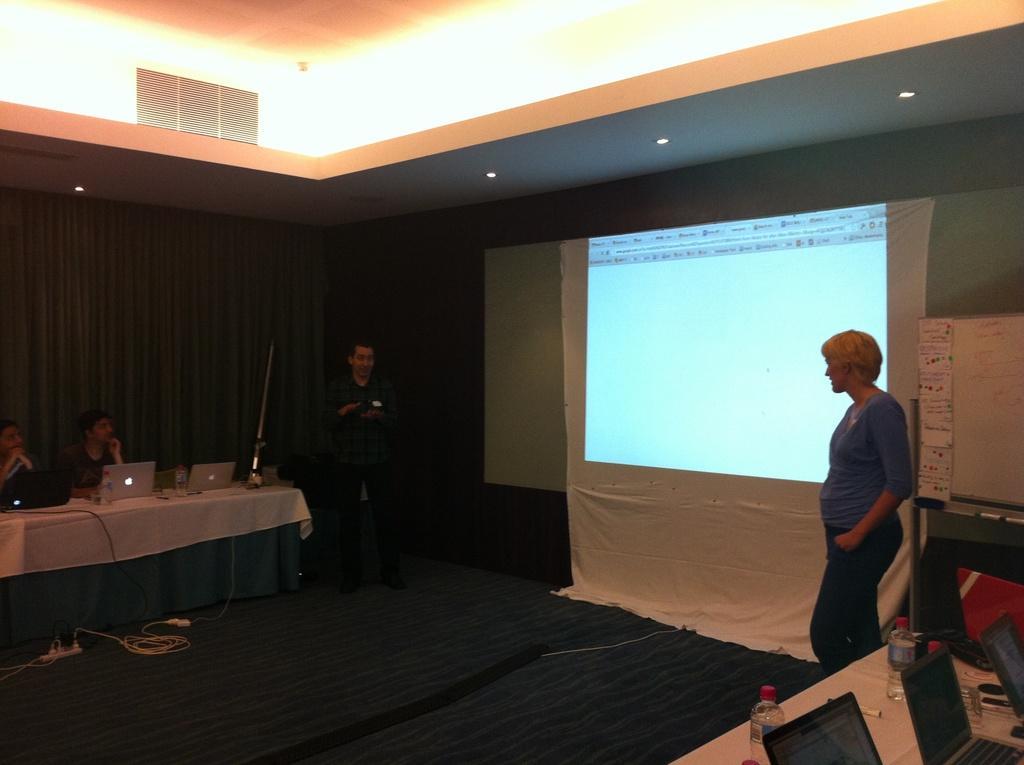Describe this image in one or two sentences. A screen is on wall. These two persons are standing. We can able to see tables and person sitting on chair. On this table there are laptops and bottles. 